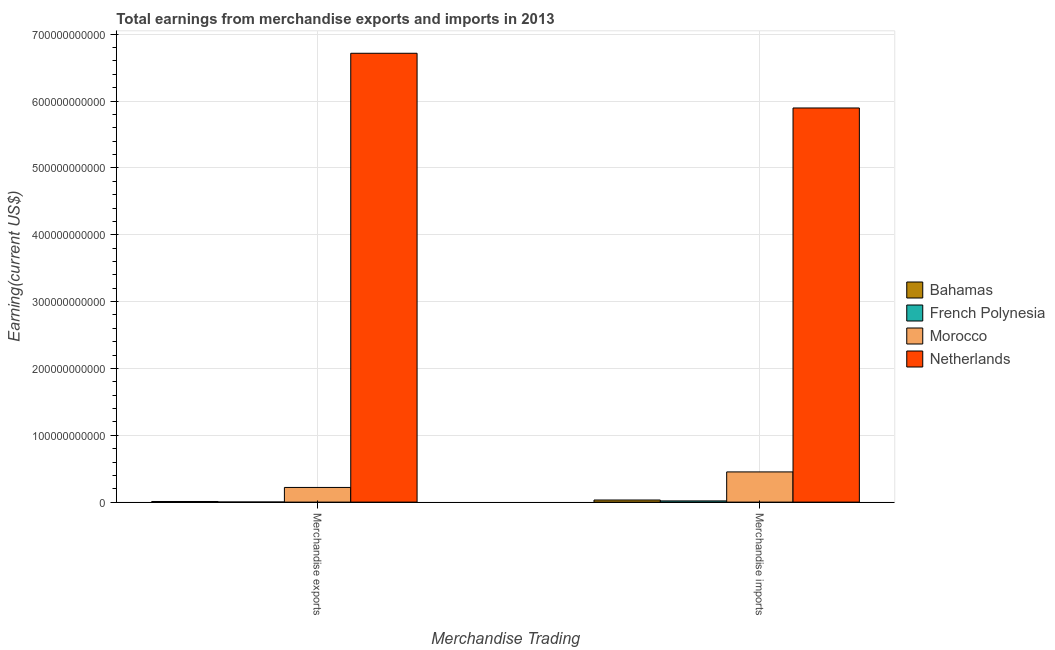How many different coloured bars are there?
Give a very brief answer. 4. How many groups of bars are there?
Offer a terse response. 2. Are the number of bars per tick equal to the number of legend labels?
Your answer should be very brief. Yes. Are the number of bars on each tick of the X-axis equal?
Ensure brevity in your answer.  Yes. How many bars are there on the 2nd tick from the left?
Give a very brief answer. 4. How many bars are there on the 1st tick from the right?
Your response must be concise. 4. What is the earnings from merchandise exports in Netherlands?
Offer a terse response. 6.72e+11. Across all countries, what is the maximum earnings from merchandise imports?
Offer a terse response. 5.90e+11. Across all countries, what is the minimum earnings from merchandise imports?
Your response must be concise. 1.81e+09. In which country was the earnings from merchandise imports minimum?
Keep it short and to the point. French Polynesia. What is the total earnings from merchandise imports in the graph?
Keep it short and to the point. 6.40e+11. What is the difference between the earnings from merchandise exports in Morocco and that in Netherlands?
Provide a short and direct response. -6.50e+11. What is the difference between the earnings from merchandise imports in Netherlands and the earnings from merchandise exports in Morocco?
Offer a terse response. 5.68e+11. What is the average earnings from merchandise imports per country?
Keep it short and to the point. 1.60e+11. What is the difference between the earnings from merchandise imports and earnings from merchandise exports in Bahamas?
Your answer should be compact. 2.21e+09. What is the ratio of the earnings from merchandise imports in Netherlands to that in French Polynesia?
Provide a succinct answer. 324.93. Is the earnings from merchandise imports in Bahamas less than that in French Polynesia?
Provide a succinct answer. No. What does the 1st bar from the left in Merchandise imports represents?
Provide a succinct answer. Bahamas. What does the 3rd bar from the right in Merchandise exports represents?
Your answer should be very brief. French Polynesia. How many countries are there in the graph?
Your response must be concise. 4. What is the difference between two consecutive major ticks on the Y-axis?
Your answer should be very brief. 1.00e+11. Are the values on the major ticks of Y-axis written in scientific E-notation?
Offer a terse response. No. How are the legend labels stacked?
Give a very brief answer. Vertical. What is the title of the graph?
Offer a very short reply. Total earnings from merchandise exports and imports in 2013. What is the label or title of the X-axis?
Ensure brevity in your answer.  Merchandise Trading. What is the label or title of the Y-axis?
Offer a terse response. Earning(current US$). What is the Earning(current US$) in Bahamas in Merchandise exports?
Your answer should be very brief. 9.55e+08. What is the Earning(current US$) in French Polynesia in Merchandise exports?
Your response must be concise. 1.51e+08. What is the Earning(current US$) in Morocco in Merchandise exports?
Provide a succinct answer. 2.20e+1. What is the Earning(current US$) in Netherlands in Merchandise exports?
Offer a very short reply. 6.72e+11. What is the Earning(current US$) of Bahamas in Merchandise imports?
Offer a terse response. 3.17e+09. What is the Earning(current US$) in French Polynesia in Merchandise imports?
Provide a succinct answer. 1.81e+09. What is the Earning(current US$) in Morocco in Merchandise imports?
Offer a terse response. 4.52e+1. What is the Earning(current US$) in Netherlands in Merchandise imports?
Provide a short and direct response. 5.90e+11. Across all Merchandise Trading, what is the maximum Earning(current US$) in Bahamas?
Your response must be concise. 3.17e+09. Across all Merchandise Trading, what is the maximum Earning(current US$) in French Polynesia?
Keep it short and to the point. 1.81e+09. Across all Merchandise Trading, what is the maximum Earning(current US$) of Morocco?
Keep it short and to the point. 4.52e+1. Across all Merchandise Trading, what is the maximum Earning(current US$) in Netherlands?
Give a very brief answer. 6.72e+11. Across all Merchandise Trading, what is the minimum Earning(current US$) of Bahamas?
Your answer should be very brief. 9.55e+08. Across all Merchandise Trading, what is the minimum Earning(current US$) in French Polynesia?
Your answer should be compact. 1.51e+08. Across all Merchandise Trading, what is the minimum Earning(current US$) in Morocco?
Provide a succinct answer. 2.20e+1. Across all Merchandise Trading, what is the minimum Earning(current US$) of Netherlands?
Keep it short and to the point. 5.90e+11. What is the total Earning(current US$) of Bahamas in the graph?
Your answer should be very brief. 4.12e+09. What is the total Earning(current US$) in French Polynesia in the graph?
Provide a succinct answer. 1.97e+09. What is the total Earning(current US$) in Morocco in the graph?
Your response must be concise. 6.72e+1. What is the total Earning(current US$) of Netherlands in the graph?
Offer a very short reply. 1.26e+12. What is the difference between the Earning(current US$) of Bahamas in Merchandise exports and that in Merchandise imports?
Provide a short and direct response. -2.21e+09. What is the difference between the Earning(current US$) in French Polynesia in Merchandise exports and that in Merchandise imports?
Give a very brief answer. -1.66e+09. What is the difference between the Earning(current US$) in Morocco in Merchandise exports and that in Merchandise imports?
Your response must be concise. -2.32e+1. What is the difference between the Earning(current US$) in Netherlands in Merchandise exports and that in Merchandise imports?
Make the answer very short. 8.19e+1. What is the difference between the Earning(current US$) of Bahamas in Merchandise exports and the Earning(current US$) of French Polynesia in Merchandise imports?
Offer a very short reply. -8.60e+08. What is the difference between the Earning(current US$) of Bahamas in Merchandise exports and the Earning(current US$) of Morocco in Merchandise imports?
Your answer should be very brief. -4.42e+1. What is the difference between the Earning(current US$) in Bahamas in Merchandise exports and the Earning(current US$) in Netherlands in Merchandise imports?
Your response must be concise. -5.89e+11. What is the difference between the Earning(current US$) of French Polynesia in Merchandise exports and the Earning(current US$) of Morocco in Merchandise imports?
Make the answer very short. -4.50e+1. What is the difference between the Earning(current US$) in French Polynesia in Merchandise exports and the Earning(current US$) in Netherlands in Merchandise imports?
Make the answer very short. -5.90e+11. What is the difference between the Earning(current US$) in Morocco in Merchandise exports and the Earning(current US$) in Netherlands in Merchandise imports?
Your response must be concise. -5.68e+11. What is the average Earning(current US$) in Bahamas per Merchandise Trading?
Ensure brevity in your answer.  2.06e+09. What is the average Earning(current US$) of French Polynesia per Merchandise Trading?
Make the answer very short. 9.83e+08. What is the average Earning(current US$) in Morocco per Merchandise Trading?
Offer a terse response. 3.36e+1. What is the average Earning(current US$) in Netherlands per Merchandise Trading?
Offer a very short reply. 6.31e+11. What is the difference between the Earning(current US$) of Bahamas and Earning(current US$) of French Polynesia in Merchandise exports?
Ensure brevity in your answer.  8.03e+08. What is the difference between the Earning(current US$) of Bahamas and Earning(current US$) of Morocco in Merchandise exports?
Ensure brevity in your answer.  -2.10e+1. What is the difference between the Earning(current US$) of Bahamas and Earning(current US$) of Netherlands in Merchandise exports?
Keep it short and to the point. -6.71e+11. What is the difference between the Earning(current US$) in French Polynesia and Earning(current US$) in Morocco in Merchandise exports?
Offer a terse response. -2.18e+1. What is the difference between the Earning(current US$) of French Polynesia and Earning(current US$) of Netherlands in Merchandise exports?
Your response must be concise. -6.71e+11. What is the difference between the Earning(current US$) in Morocco and Earning(current US$) in Netherlands in Merchandise exports?
Give a very brief answer. -6.50e+11. What is the difference between the Earning(current US$) in Bahamas and Earning(current US$) in French Polynesia in Merchandise imports?
Your answer should be very brief. 1.35e+09. What is the difference between the Earning(current US$) of Bahamas and Earning(current US$) of Morocco in Merchandise imports?
Make the answer very short. -4.20e+1. What is the difference between the Earning(current US$) in Bahamas and Earning(current US$) in Netherlands in Merchandise imports?
Give a very brief answer. -5.87e+11. What is the difference between the Earning(current US$) in French Polynesia and Earning(current US$) in Morocco in Merchandise imports?
Offer a terse response. -4.34e+1. What is the difference between the Earning(current US$) in French Polynesia and Earning(current US$) in Netherlands in Merchandise imports?
Your answer should be very brief. -5.88e+11. What is the difference between the Earning(current US$) of Morocco and Earning(current US$) of Netherlands in Merchandise imports?
Your response must be concise. -5.45e+11. What is the ratio of the Earning(current US$) of Bahamas in Merchandise exports to that in Merchandise imports?
Offer a very short reply. 0.3. What is the ratio of the Earning(current US$) in French Polynesia in Merchandise exports to that in Merchandise imports?
Offer a terse response. 0.08. What is the ratio of the Earning(current US$) of Morocco in Merchandise exports to that in Merchandise imports?
Ensure brevity in your answer.  0.49. What is the ratio of the Earning(current US$) of Netherlands in Merchandise exports to that in Merchandise imports?
Offer a terse response. 1.14. What is the difference between the highest and the second highest Earning(current US$) in Bahamas?
Offer a terse response. 2.21e+09. What is the difference between the highest and the second highest Earning(current US$) of French Polynesia?
Your response must be concise. 1.66e+09. What is the difference between the highest and the second highest Earning(current US$) in Morocco?
Give a very brief answer. 2.32e+1. What is the difference between the highest and the second highest Earning(current US$) in Netherlands?
Provide a succinct answer. 8.19e+1. What is the difference between the highest and the lowest Earning(current US$) of Bahamas?
Provide a succinct answer. 2.21e+09. What is the difference between the highest and the lowest Earning(current US$) in French Polynesia?
Provide a short and direct response. 1.66e+09. What is the difference between the highest and the lowest Earning(current US$) in Morocco?
Give a very brief answer. 2.32e+1. What is the difference between the highest and the lowest Earning(current US$) of Netherlands?
Offer a terse response. 8.19e+1. 